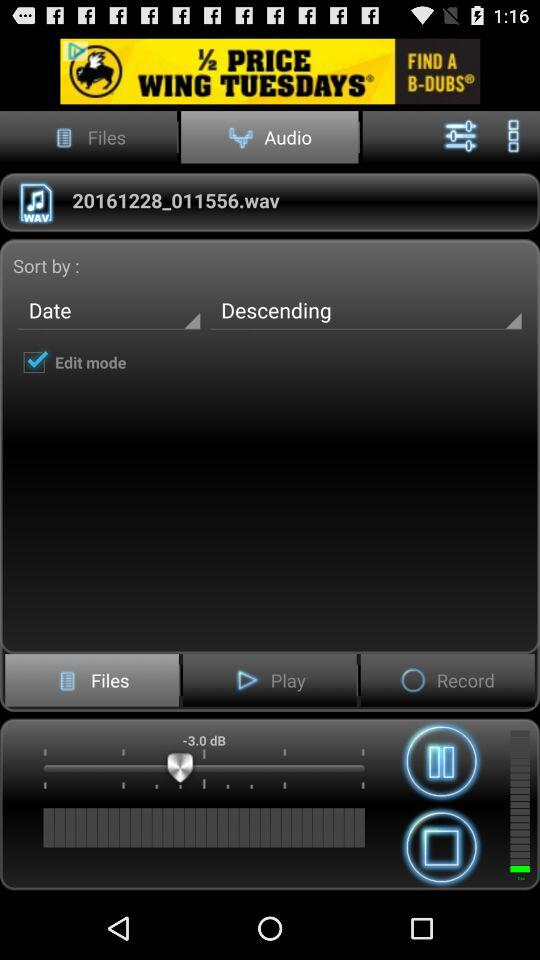What is the title of the audio? The title of the audio is 20161228_011556.wav. 